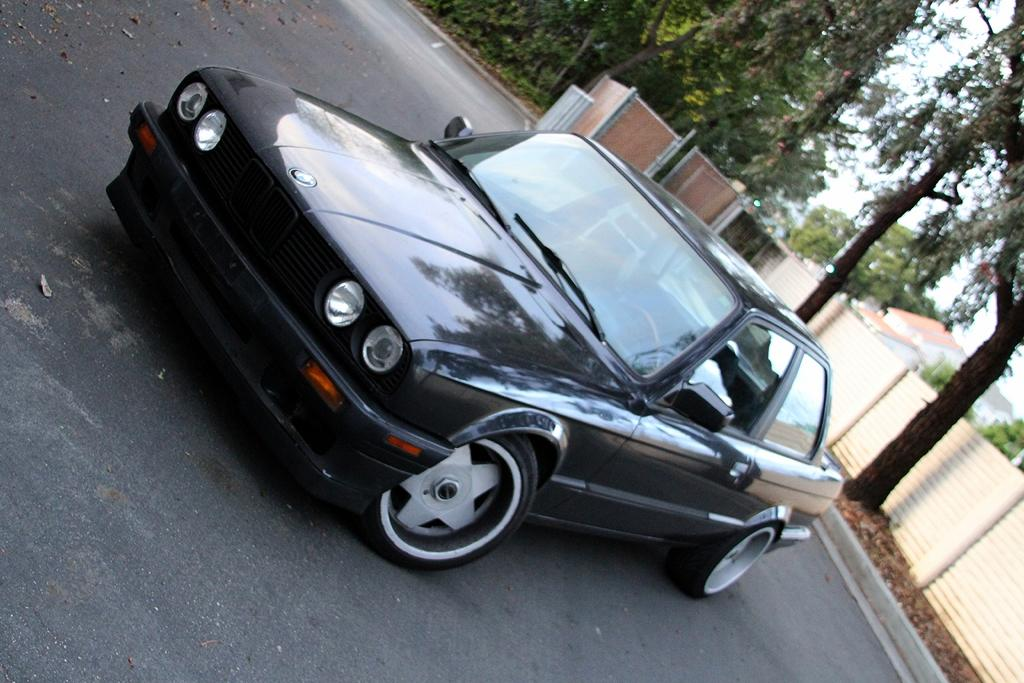What type of view is shown in the image? The image is an outside view. What can be seen on the road in the image? There is a car on the road. What is located on the right side of the image? There is a wall on the right side, and two trees beside it. What can be seen in the background of the image? There are houses and trees in the background. What type of wood is used to build the train in the image? There is no train present in the image; it features a car on the road and a wall with trees on the right side. 